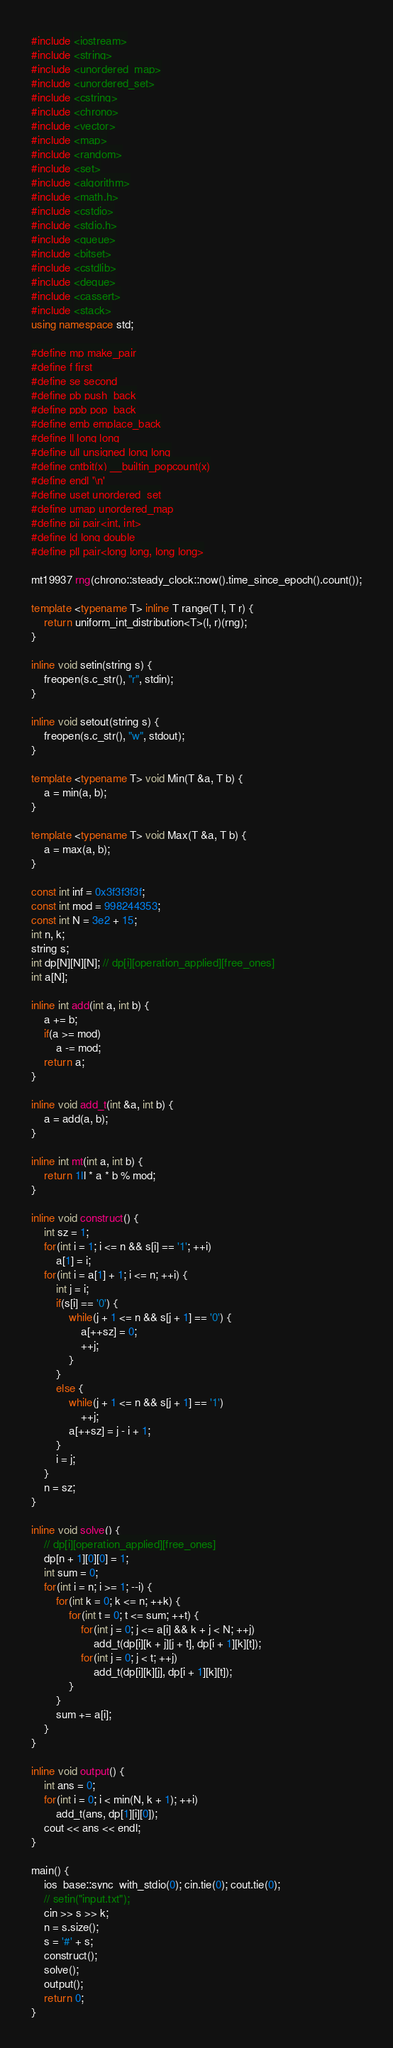<code> <loc_0><loc_0><loc_500><loc_500><_C++_>#include <iostream>
#include <string>
#include <unordered_map>
#include <unordered_set>
#include <cstring>
#include <chrono>
#include <vector>
#include <map>
#include <random>
#include <set>
#include <algorithm>
#include <math.h>
#include <cstdio>
#include <stdio.h>
#include <queue>
#include <bitset>
#include <cstdlib>
#include <deque>
#include <cassert>
#include <stack>
using namespace std;

#define mp make_pair
#define f first
#define se second
#define pb push_back
#define ppb pop_back
#define emb emplace_back
#define ll long long
#define ull unsigned long long
#define cntbit(x) __builtin_popcount(x)
#define endl '\n'
#define uset unordered_set
#define umap unordered_map
#define pii pair<int, int>
#define ld long double
#define pll pair<long long, long long>

mt19937 rng(chrono::steady_clock::now().time_since_epoch().count());

template <typename T> inline T range(T l, T r) {
    return uniform_int_distribution<T>(l, r)(rng);
}

inline void setin(string s) {
    freopen(s.c_str(), "r", stdin);
}

inline void setout(string s) {
    freopen(s.c_str(), "w", stdout);
}

template <typename T> void Min(T &a, T b) {
    a = min(a, b);
}

template <typename T> void Max(T &a, T b) {
    a = max(a, b);
}

const int inf = 0x3f3f3f3f;
const int mod = 998244353;
const int N = 3e2 + 15;
int n, k;
string s;
int dp[N][N][N]; // dp[i][operation_applied][free_ones]
int a[N];

inline int add(int a, int b) {
    a += b;
    if(a >= mod)
        a -= mod;
    return a;
}

inline void add_t(int &a, int b) {
    a = add(a, b);
}

inline int mt(int a, int b) {
    return 1ll * a * b % mod;
}

inline void construct() {
    int sz = 1;
    for(int i = 1; i <= n && s[i] == '1'; ++i)
        a[1] = i;
    for(int i = a[1] + 1; i <= n; ++i) {
        int j = i;
        if(s[i] == '0') {
            while(j + 1 <= n && s[j + 1] == '0') {
                a[++sz] = 0;
                ++j;
            }
        }
        else {
            while(j + 1 <= n && s[j + 1] == '1')
                ++j;
            a[++sz] = j - i + 1;
        }
        i = j;
    }
    n = sz;
}

inline void solve() {
    // dp[i][operation_applied][free_ones]
    dp[n + 1][0][0] = 1;
    int sum = 0;
    for(int i = n; i >= 1; --i) {
        for(int k = 0; k <= n; ++k) {
            for(int t = 0; t <= sum; ++t) {
                for(int j = 0; j <= a[i] && k + j < N; ++j)
                    add_t(dp[i][k + j][j + t], dp[i + 1][k][t]);
                for(int j = 0; j < t; ++j)
                    add_t(dp[i][k][j], dp[i + 1][k][t]);
            }
        }
        sum += a[i];
    }
}

inline void output() {
    int ans = 0;
    for(int i = 0; i < min(N, k + 1); ++i)
        add_t(ans, dp[1][i][0]);
    cout << ans << endl;
}

main() {
    ios_base::sync_with_stdio(0); cin.tie(0); cout.tie(0);
    // setin("input.txt");
    cin >> s >> k;
    n = s.size();
    s = '#' + s;
    construct();
    solve();
    output();
    return 0;
}</code> 